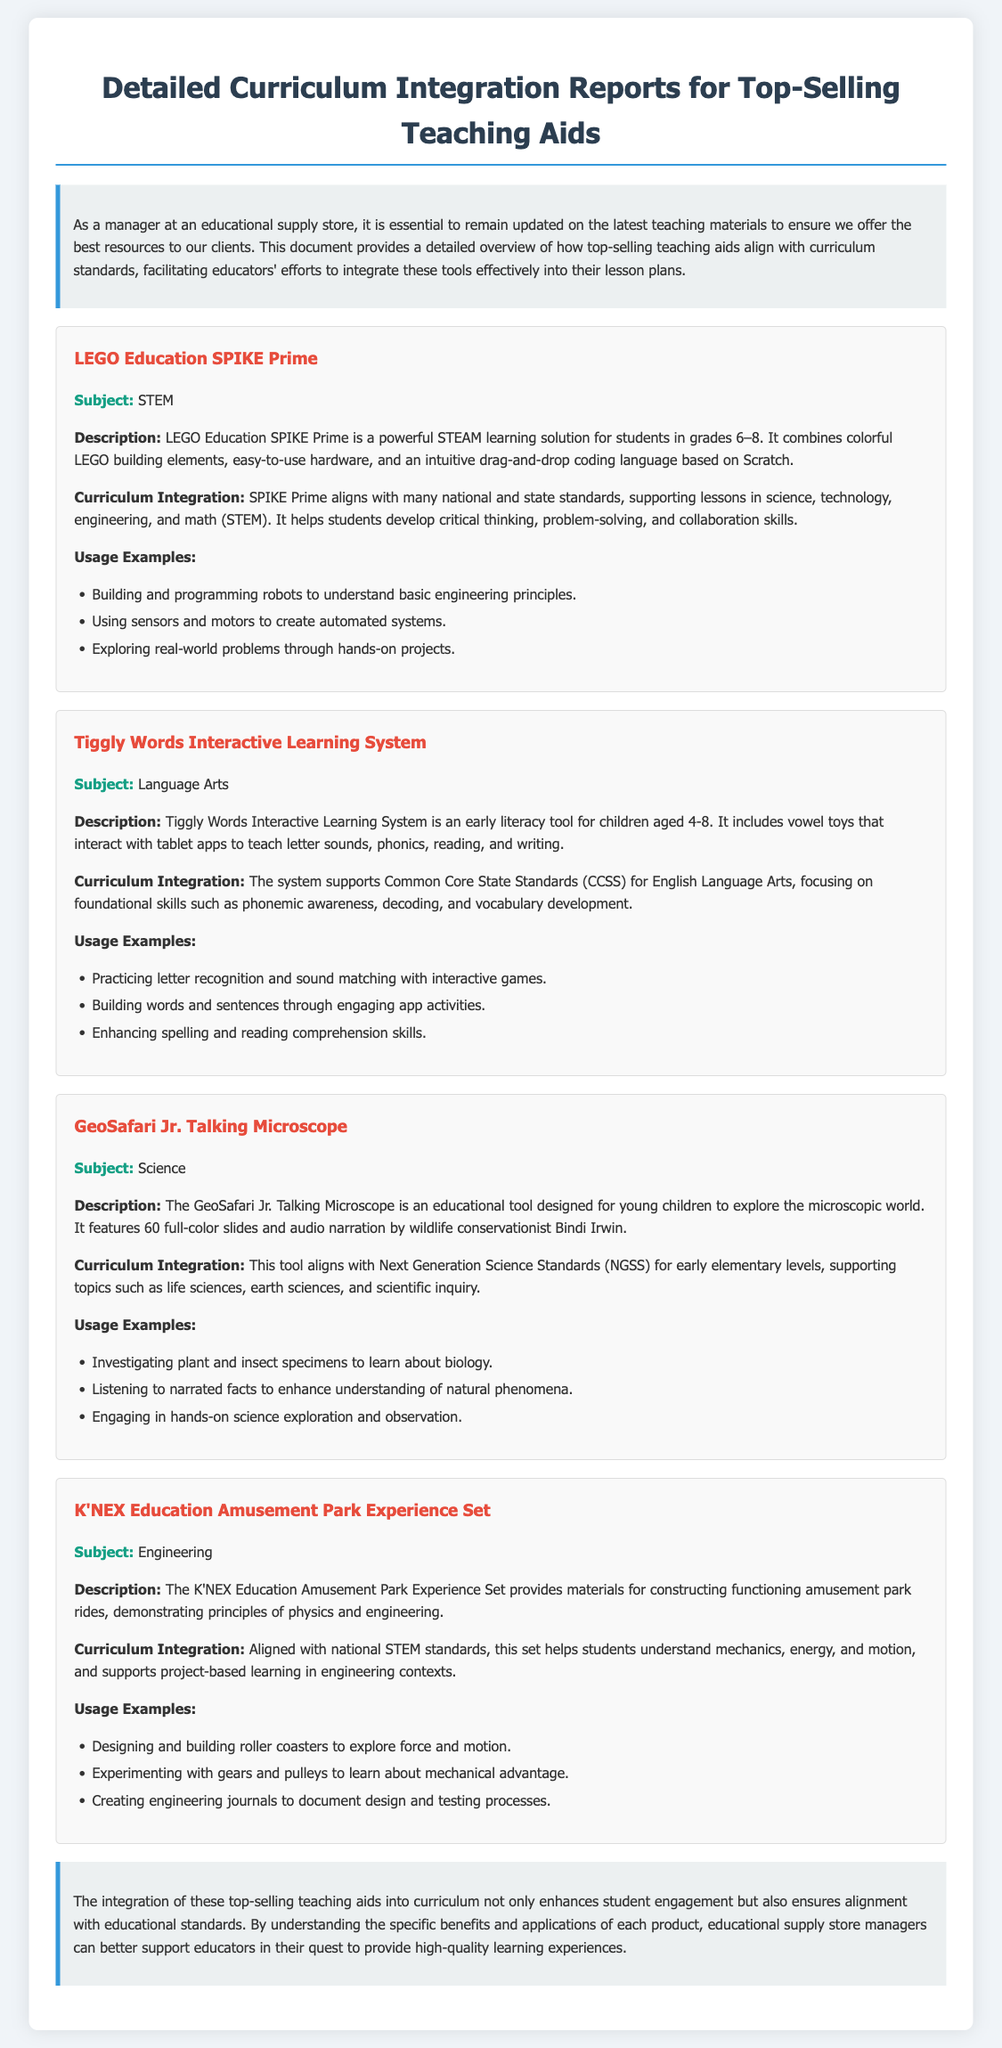What is the first teaching aid mentioned in the document? The first teaching aid discussed is LEGO Education SPIKE Prime.
Answer: LEGO Education SPIKE Prime What subject does the Tiggly Words Interactive Learning System focus on? The Tiggly Words Interactive Learning System focuses on Language Arts.
Answer: Language Arts What is the grade range for the LEGO Education SPIKE Prime? LEGO Education SPIKE Prime is targeted at students in grades 6–8.
Answer: Grades 6–8 Which standards does the GeoSafari Jr. Talking Microscope align with? The GeoSafari Jr. Talking Microscope aligns with Next Generation Science Standards (NGSS).
Answer: Next Generation Science Standards (NGSS) How many slides does the GeoSafari Jr. Talking Microscope feature? The GeoSafari Jr. Talking Microscope features 60 full-color slides.
Answer: 60 full-color slides What type of learning does the K'NEX Education Amusement Park Experience Set represent? The K'NEX Education Amusement Park Experience Set represents project-based learning in engineering contexts.
Answer: Project-based learning in engineering contexts What is a key outcome of using LEGO Education SPIKE Prime according to the document? A key outcome is the development of critical thinking, problem-solving, and collaboration skills.
Answer: Critical thinking, problem-solving, and collaboration skills What age group is the Tiggly Words Interactive Learning System designed for? The Tiggly Words Interactive Learning System is designed for children aged 4-8.
Answer: Aged 4-8 What type of document is this transcript considered? This transcript is considered a detailed curriculum integration report.
Answer: Detailed curriculum integration report 